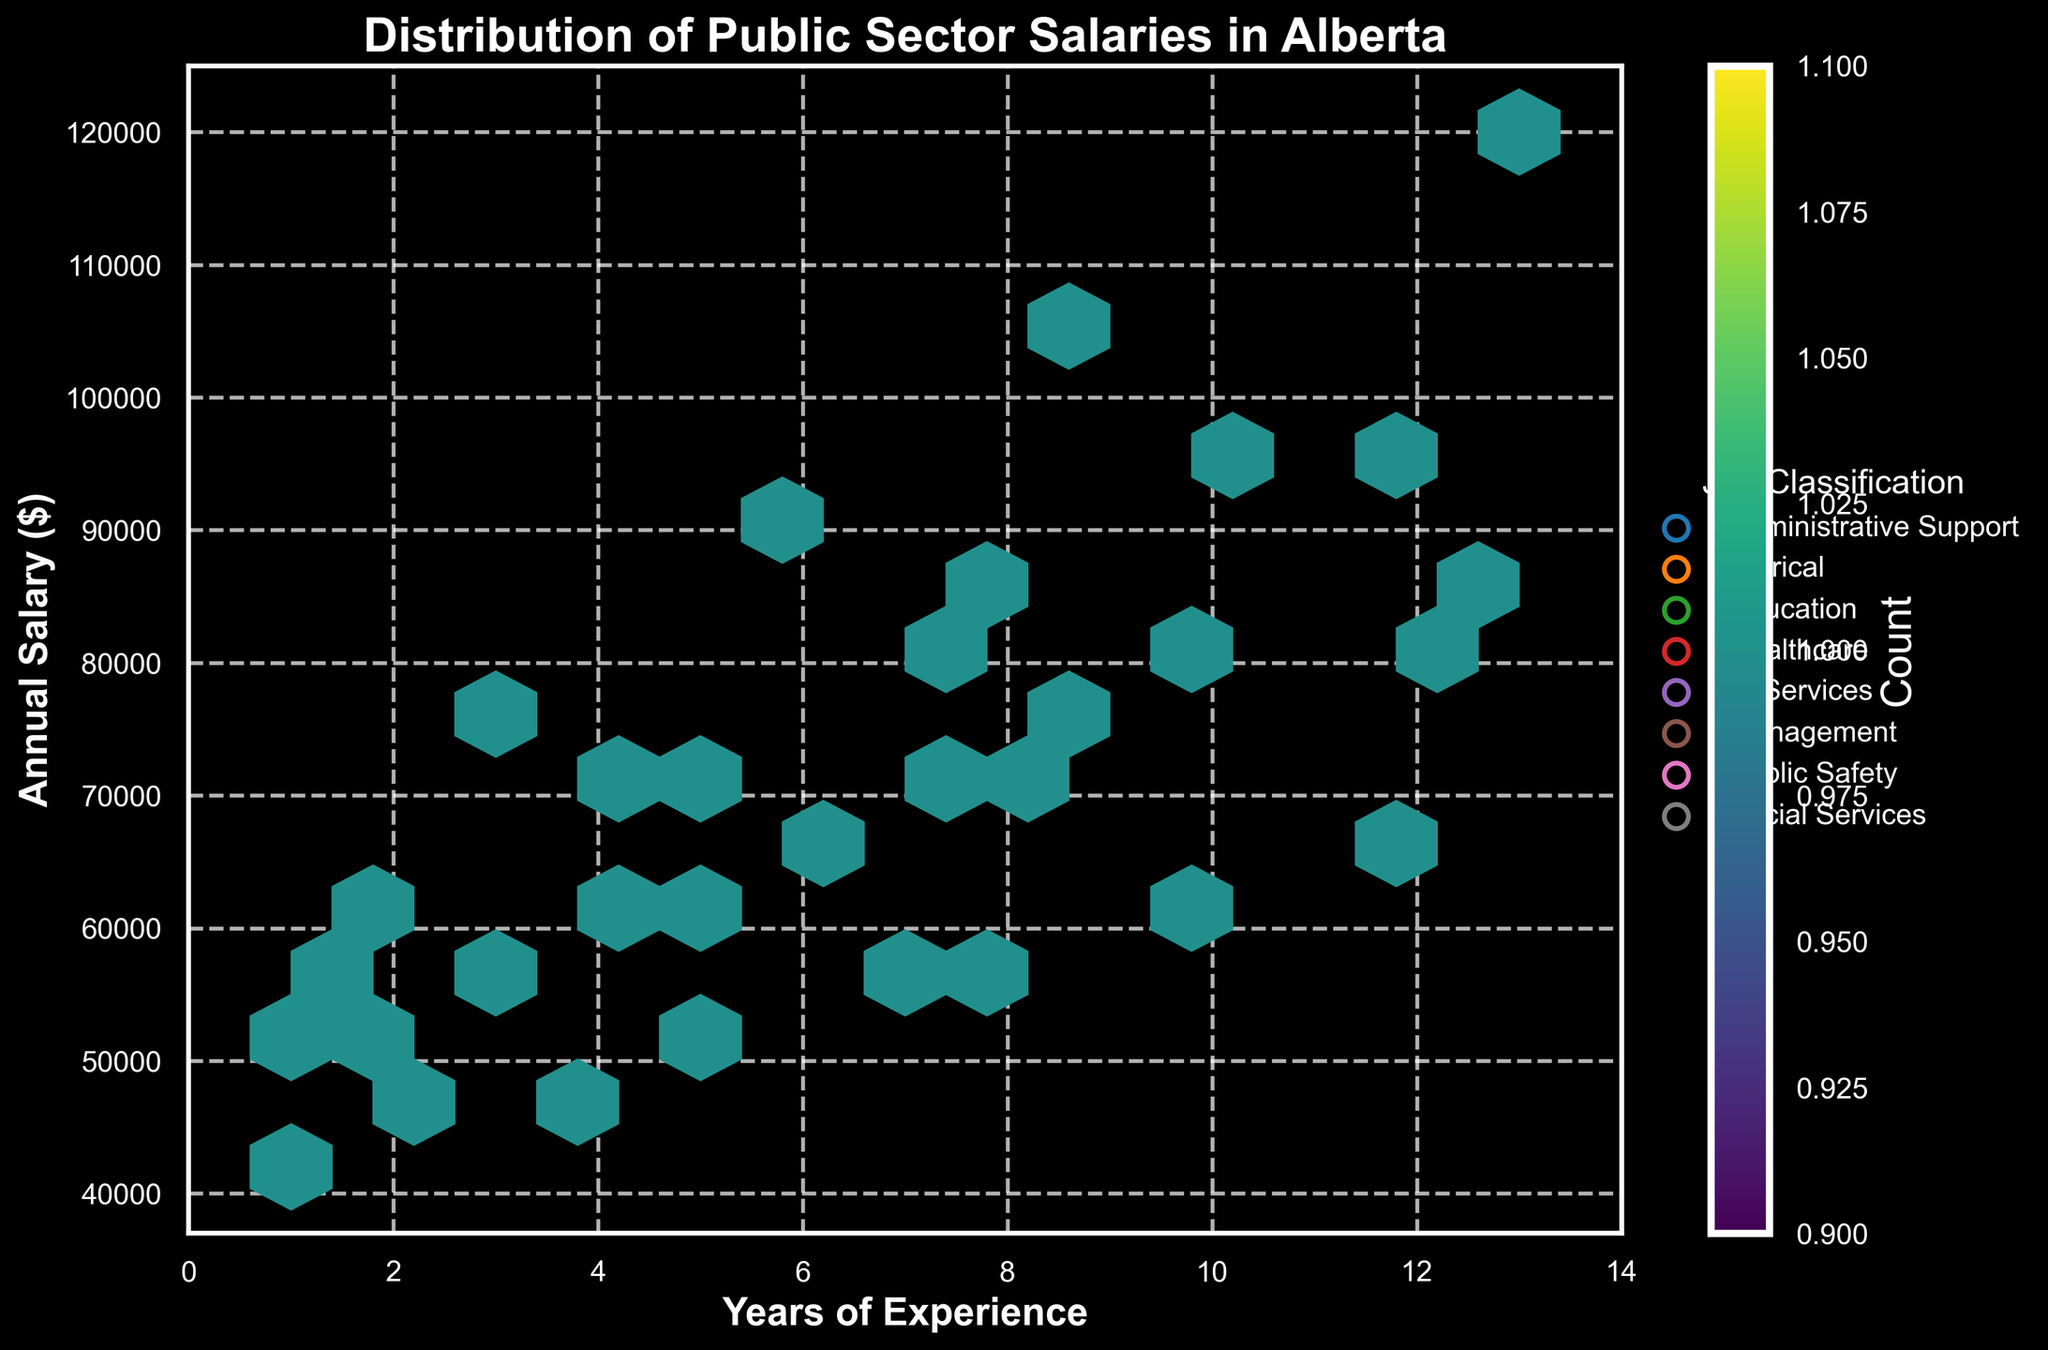Which job classification has the highest average annual salary? To determine the job classification with the highest average annual salary, calculate the average salary for each job classification by summing the salaries and dividing by the number of data points per classification. Management shows the highest range of salaries, indicating the highest average.
Answer: Management What is the general trend between years of experience and annual salary? Observe the hexbin plot where most hexagons' colors (indicating counts) and their positioning show a trend. As years of experience increase, annual salary also increases. This positive correlation is evident from the increasing concentration of hexagons in the top-right area of the plot.
Answer: Positive correlation Which job classification has the widest range of annual salaries? By comparing the range of annual salaries within each job classification's scatter points, Management exhibits the widest range with salaries from 75,000 to 120,000.
Answer: Management How many job classifications are represented in the plot? The legend lists the job classifications distinguished by unique colors and symbols. Count the distinct classifications: Administrative Support, Clerical, Education, Healthcare, IT Services, Management, Public Safety, Social Services.
Answer: 8 What is the approximate annual salary for someone with 5 years of experience in IT Services? Locate the hexagons around the 5-year mark on the x-axis and the corresponding salaries on the y-axis. For IT Services (should be verified by legend color), the salary approximates to around 70,000.
Answer: About 70,000 Are there any job classifications with comparable salary ranges and years of experience? By comparing hexagons for different classifications, Public Safety and Social Services have overlaps in both salary ranges and years of experience (approximately 50,000 to 80,000 over 1 to 10 years).
Answer: Public Safety and Social Services What is the count of data points with an annual salary between 60,000 and 70,000 across all job classifications? Utilize the color bar to gauge the count, and observe the corresponding hexagons within the 60,000-70,000 salary range. This estimate involves counting multiple overlapping hexagons.
Answer: Varied but around 2-3 per job type Which job classification has the highest concentration of salaries around the median range of 60,000-80,000? Examine the hexbin plot for the densest hexagons within the 60,000-80,000 salary range and cross-reference with the legend. Healthcare shows a higher density in this range.
Answer: Healthcare How does the salary distribution of Healthcare compare to Education for 2 years of experience? Locate the hexagons at the 2-year mark along the x-axis for Healthcare and Education, comparing the salary values. Healthcare salaries range higher (around 60,000) compared to Education (around 55,000).
Answer: Healthcare is higher than Education What impact does having more than 10 years of experience have on salaries within the public sector? Inspect the hexbin plot, noting hexagons beyond 10 years of experience on the x-axis and corresponding salary levels on the y-axis. There is a noticeable increase in salaries, often exceeding 80,000, reflecting higher earnings with higher experience.
Answer: Salaries increase significantly 